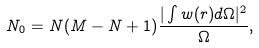<formula> <loc_0><loc_0><loc_500><loc_500>N _ { 0 } = N ( M - N + 1 ) \frac { | \int w ( r ) d \Omega | ^ { 2 } } { \Omega } ,</formula> 